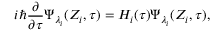Convert formula to latex. <formula><loc_0><loc_0><loc_500><loc_500>i \hbar { } { \partial } { \partial \tau } \Psi _ { \lambda _ { i } } ( Z _ { i } , \tau ) = H _ { i } ( \tau ) \Psi _ { \lambda _ { i } } ( Z _ { i } , \tau ) ,</formula> 